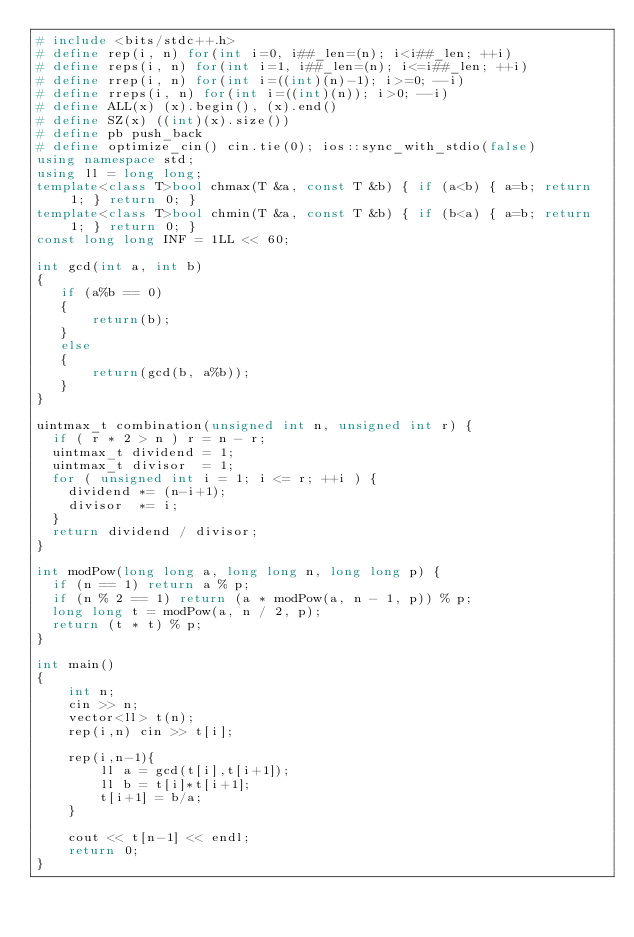Convert code to text. <code><loc_0><loc_0><loc_500><loc_500><_C++_># include <bits/stdc++.h>
# define rep(i, n) for(int i=0, i##_len=(n); i<i##_len; ++i)
# define reps(i, n) for(int i=1, i##_len=(n); i<=i##_len; ++i)
# define rrep(i, n) for(int i=((int)(n)-1); i>=0; --i)
# define rreps(i, n) for(int i=((int)(n)); i>0; --i)
# define ALL(x) (x).begin(), (x).end()
# define SZ(x) ((int)(x).size())
# define pb push_back
# define optimize_cin() cin.tie(0); ios::sync_with_stdio(false)
using namespace std;
using ll = long long;
template<class T>bool chmax(T &a, const T &b) { if (a<b) { a=b; return 1; } return 0; }
template<class T>bool chmin(T &a, const T &b) { if (b<a) { a=b; return 1; } return 0; }
const long long INF = 1LL << 60;

int gcd(int a, int b)
{
   if (a%b == 0)
   {
       return(b);
   }
   else
   {
       return(gcd(b, a%b));
   }
}

uintmax_t combination(unsigned int n, unsigned int r) {
  if ( r * 2 > n ) r = n - r;
  uintmax_t dividend = 1;
  uintmax_t divisor  = 1;
  for ( unsigned int i = 1; i <= r; ++i ) {
    dividend *= (n-i+1);
    divisor  *= i;
  }
  return dividend / divisor;
}

int modPow(long long a, long long n, long long p) {
  if (n == 1) return a % p;
  if (n % 2 == 1) return (a * modPow(a, n - 1, p)) % p;
  long long t = modPow(a, n / 2, p);
  return (t * t) % p;
}

int main()
{
    int n;
    cin >> n;
    vector<ll> t(n);
    rep(i,n) cin >> t[i];

    rep(i,n-1){
        ll a = gcd(t[i],t[i+1]);
        ll b = t[i]*t[i+1];
        t[i+1] = b/a;
    }

    cout << t[n-1] << endl;
    return 0;
}</code> 